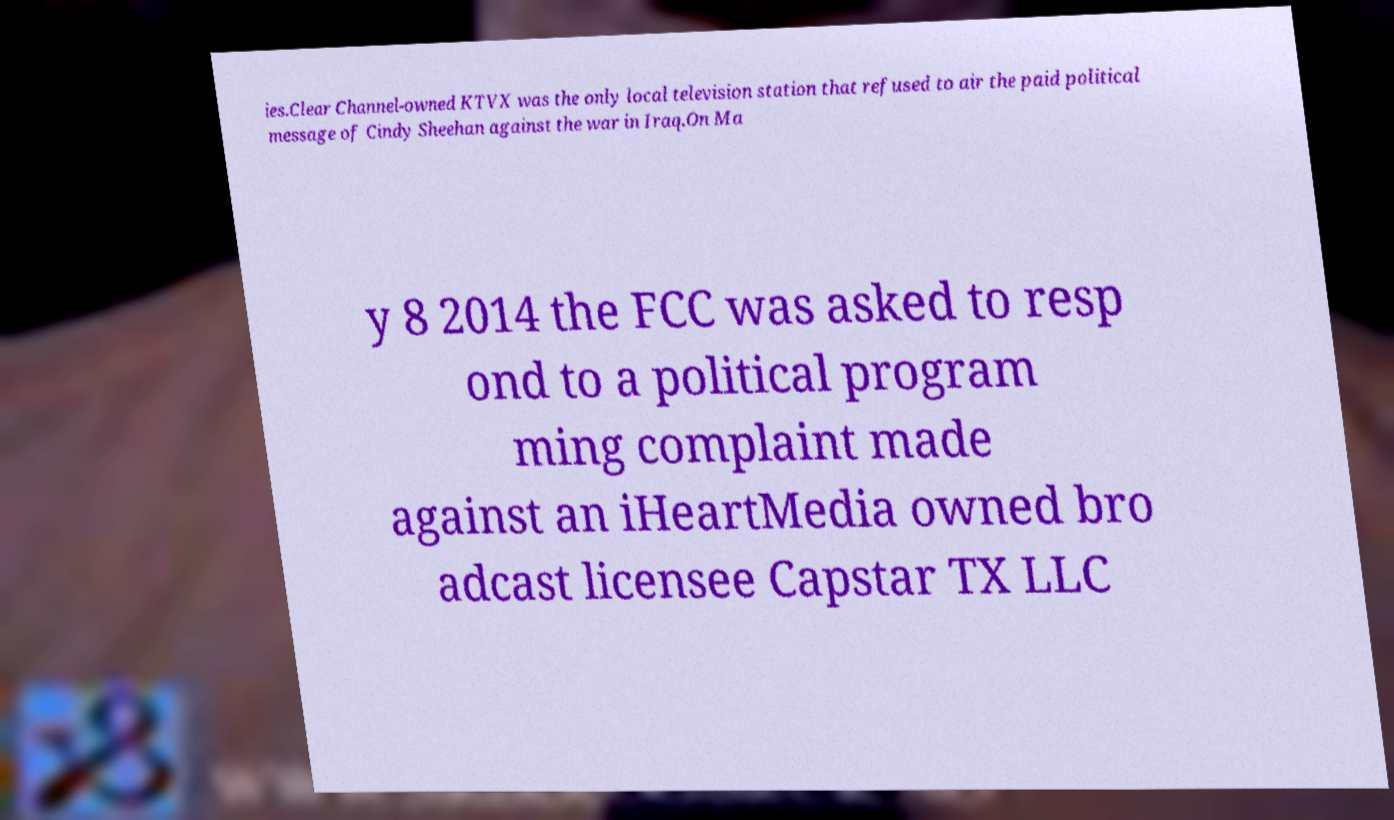Could you assist in decoding the text presented in this image and type it out clearly? ies.Clear Channel-owned KTVX was the only local television station that refused to air the paid political message of Cindy Sheehan against the war in Iraq.On Ma y 8 2014 the FCC was asked to resp ond to a political program ming complaint made against an iHeartMedia owned bro adcast licensee Capstar TX LLC 